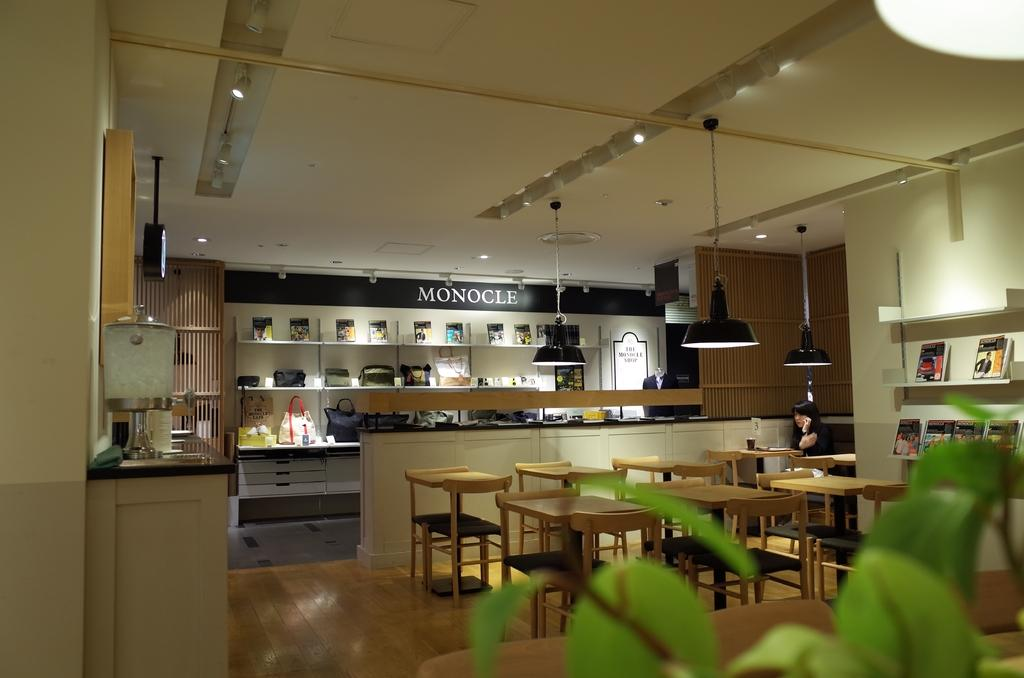What type of space is shown in the image? The image depicts the interior of a room. What can be found in the room? There are plants, chairs, tables, lights, a woman seated on a chair, and books in the room. How many trucks are parked inside the room in the image? There are no trucks present in the image; it depicts the interior of a room with various objects and a woman seated on a chair. 